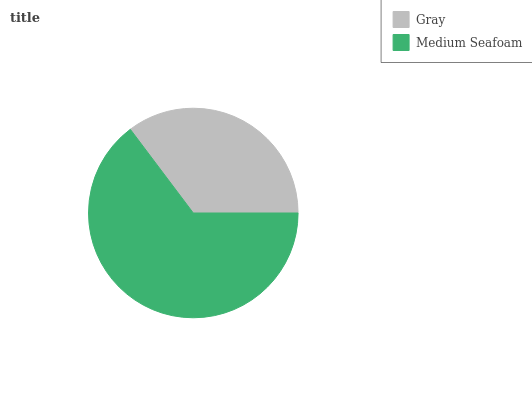Is Gray the minimum?
Answer yes or no. Yes. Is Medium Seafoam the maximum?
Answer yes or no. Yes. Is Medium Seafoam the minimum?
Answer yes or no. No. Is Medium Seafoam greater than Gray?
Answer yes or no. Yes. Is Gray less than Medium Seafoam?
Answer yes or no. Yes. Is Gray greater than Medium Seafoam?
Answer yes or no. No. Is Medium Seafoam less than Gray?
Answer yes or no. No. Is Medium Seafoam the high median?
Answer yes or no. Yes. Is Gray the low median?
Answer yes or no. Yes. Is Gray the high median?
Answer yes or no. No. Is Medium Seafoam the low median?
Answer yes or no. No. 